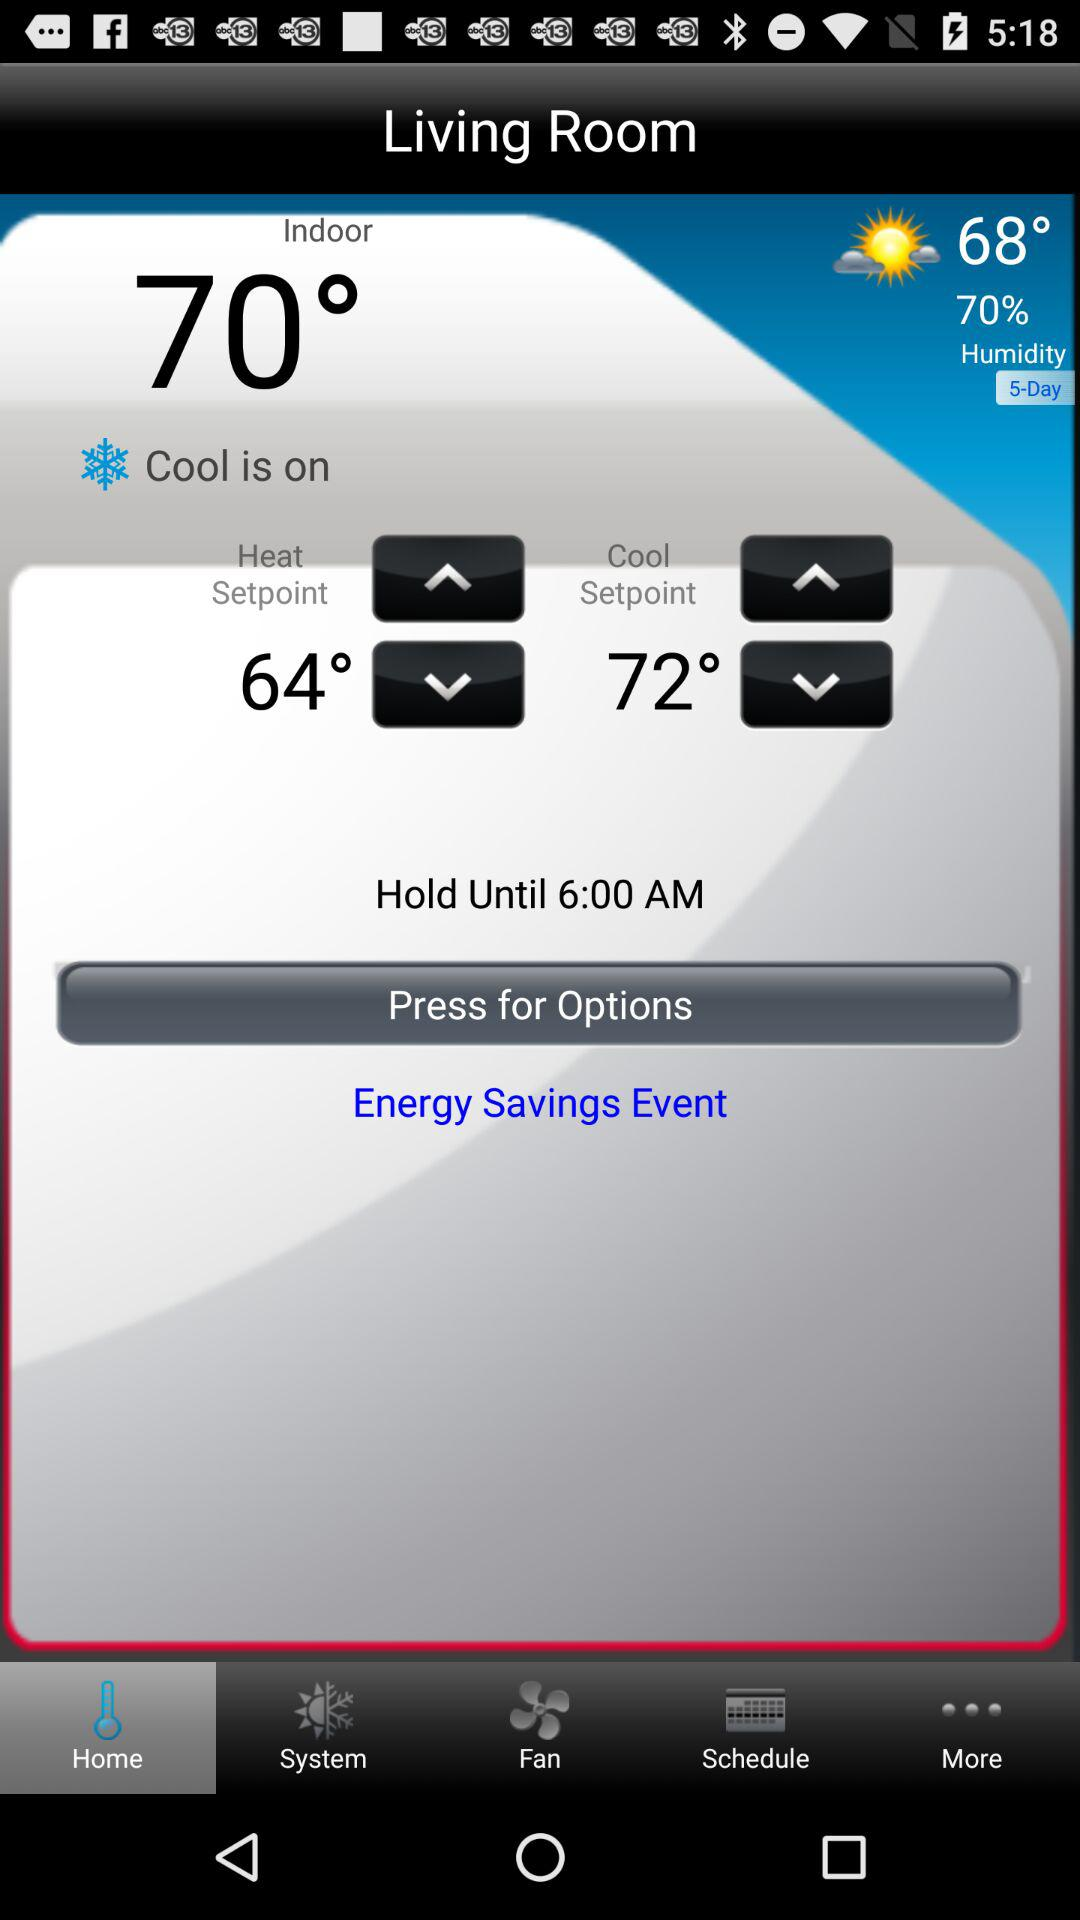Which tab is currently selected? The currently selected tab is "Home". 